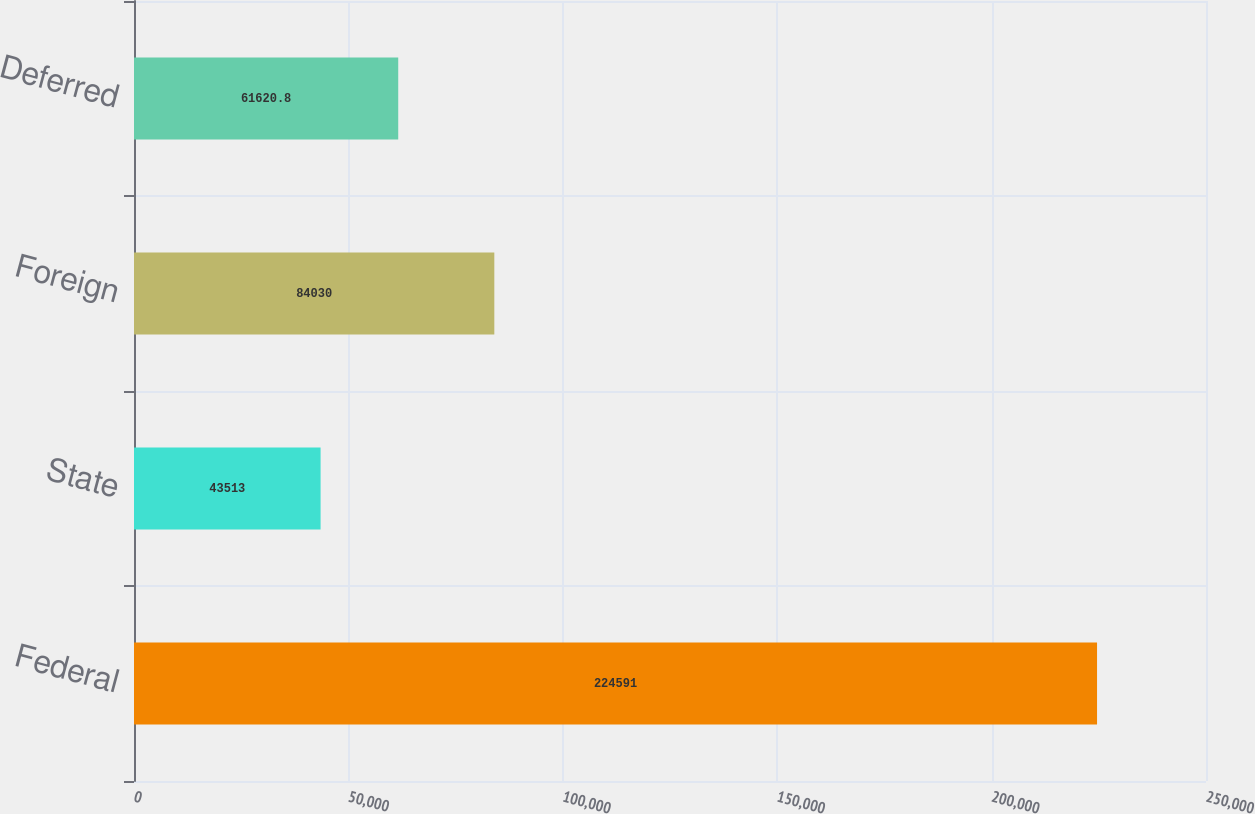<chart> <loc_0><loc_0><loc_500><loc_500><bar_chart><fcel>Federal<fcel>State<fcel>Foreign<fcel>Deferred<nl><fcel>224591<fcel>43513<fcel>84030<fcel>61620.8<nl></chart> 